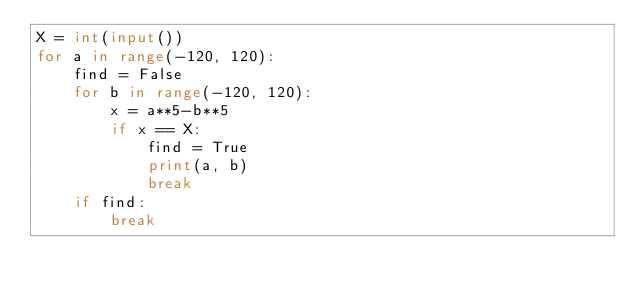Convert code to text. <code><loc_0><loc_0><loc_500><loc_500><_Python_>X = int(input())
for a in range(-120, 120):
    find = False
    for b in range(-120, 120):
        x = a**5-b**5
        if x == X:
            find = True
            print(a, b)
            break
    if find:
        break
</code> 